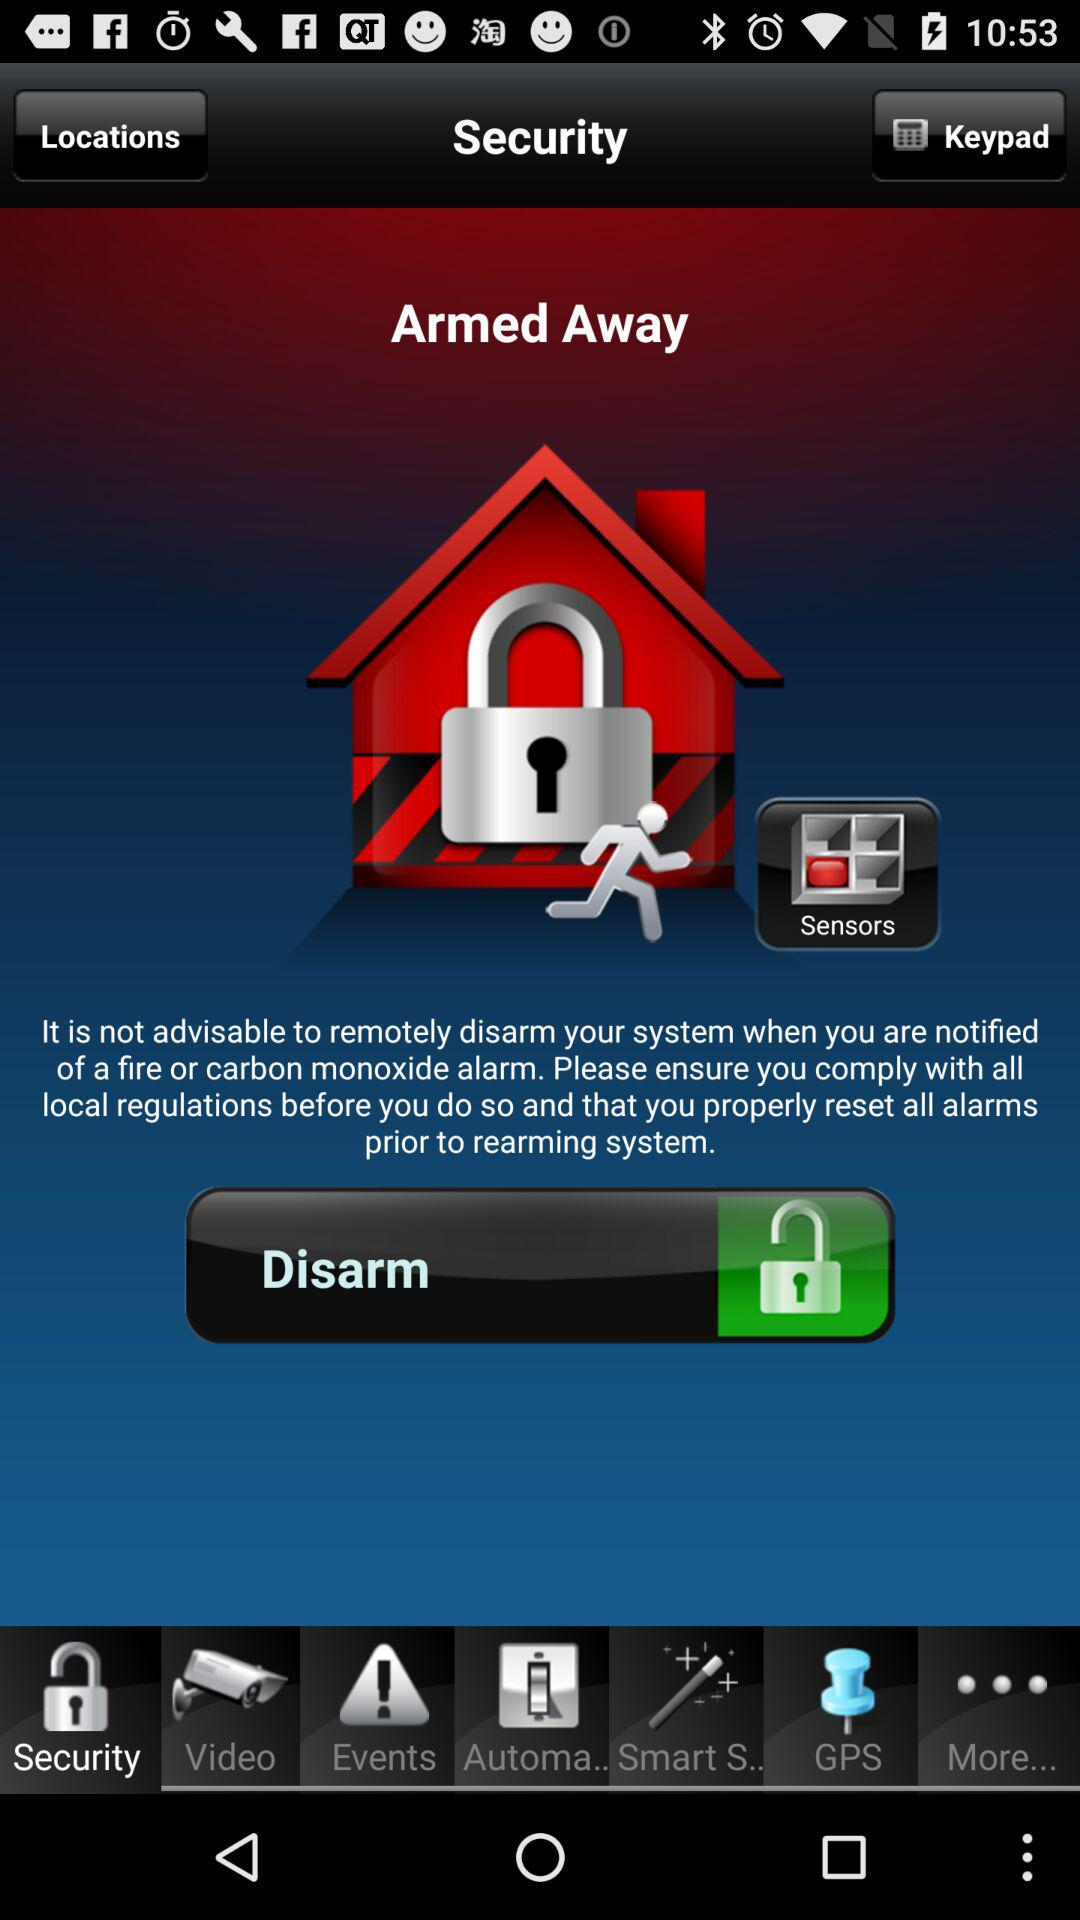Which tab is selected? The selected tab is "Security". 